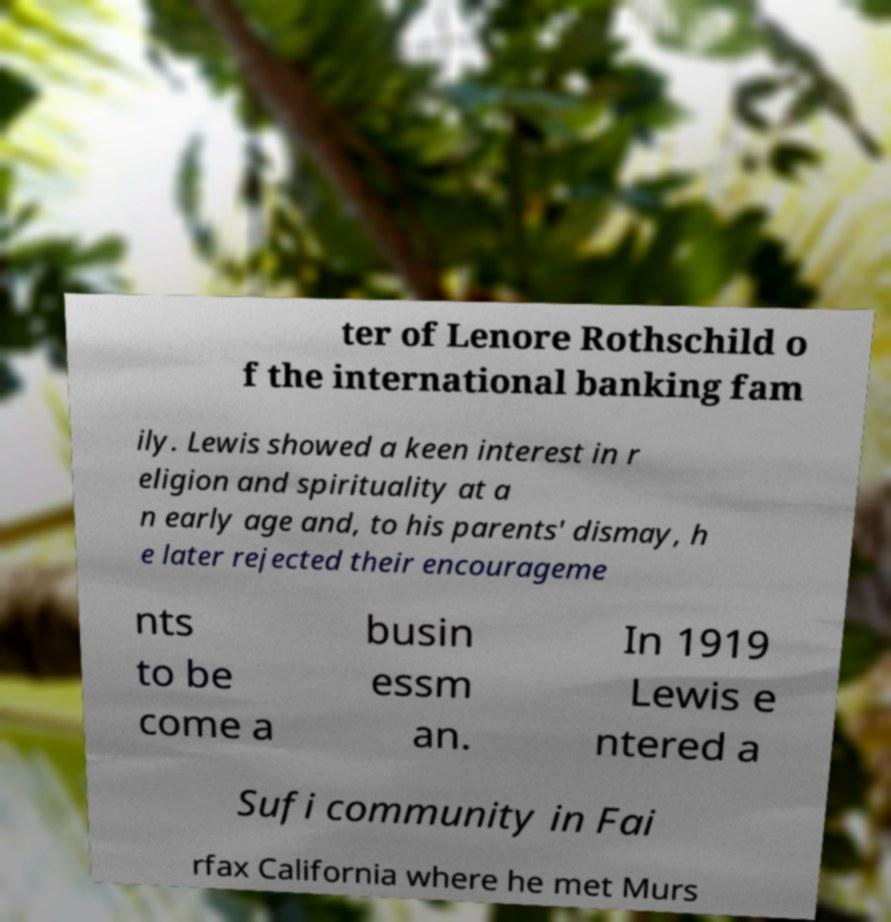Could you assist in decoding the text presented in this image and type it out clearly? ter of Lenore Rothschild o f the international banking fam ily. Lewis showed a keen interest in r eligion and spirituality at a n early age and, to his parents' dismay, h e later rejected their encourageme nts to be come a busin essm an. In 1919 Lewis e ntered a Sufi community in Fai rfax California where he met Murs 